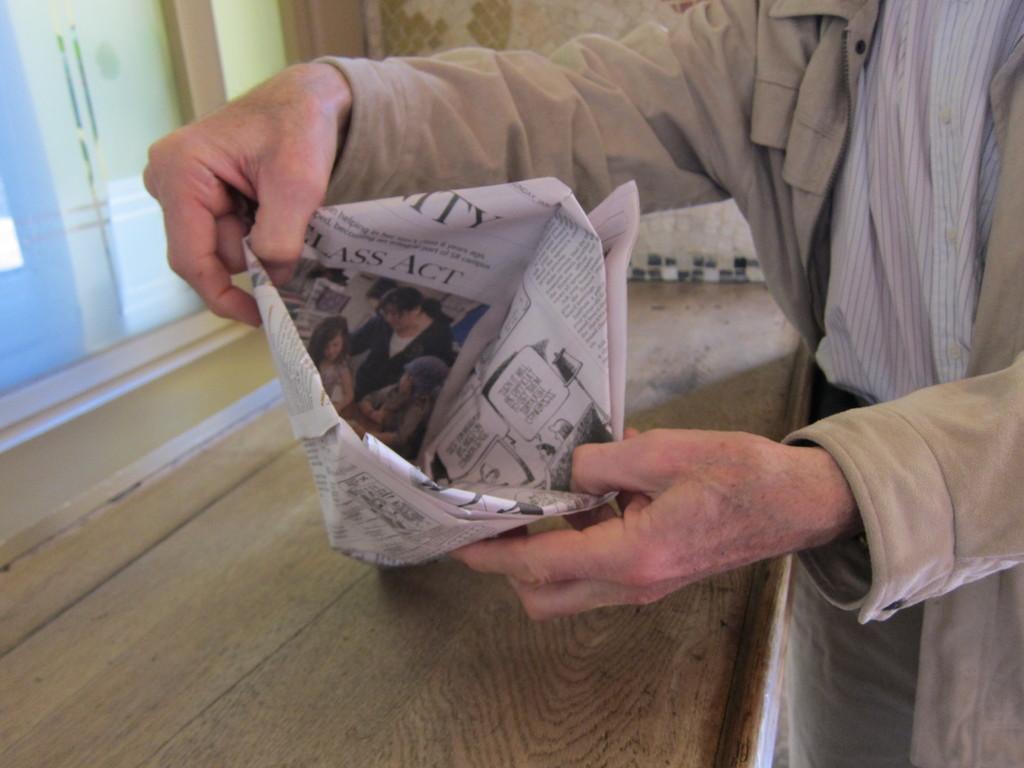How would you summarize this image in a sentence or two? In this image, we can see the hands of a person holding the paper craft. We can see some wood and the wall. We can also see some glass on the left. 